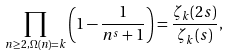Convert formula to latex. <formula><loc_0><loc_0><loc_500><loc_500>\prod _ { n \geq 2 , \Omega ( n ) = k } \left ( 1 - \frac { 1 } { n ^ { s } + 1 } \right ) = \frac { \zeta _ { k } ( 2 s ) } { \zeta _ { k } ( s ) } ,</formula> 